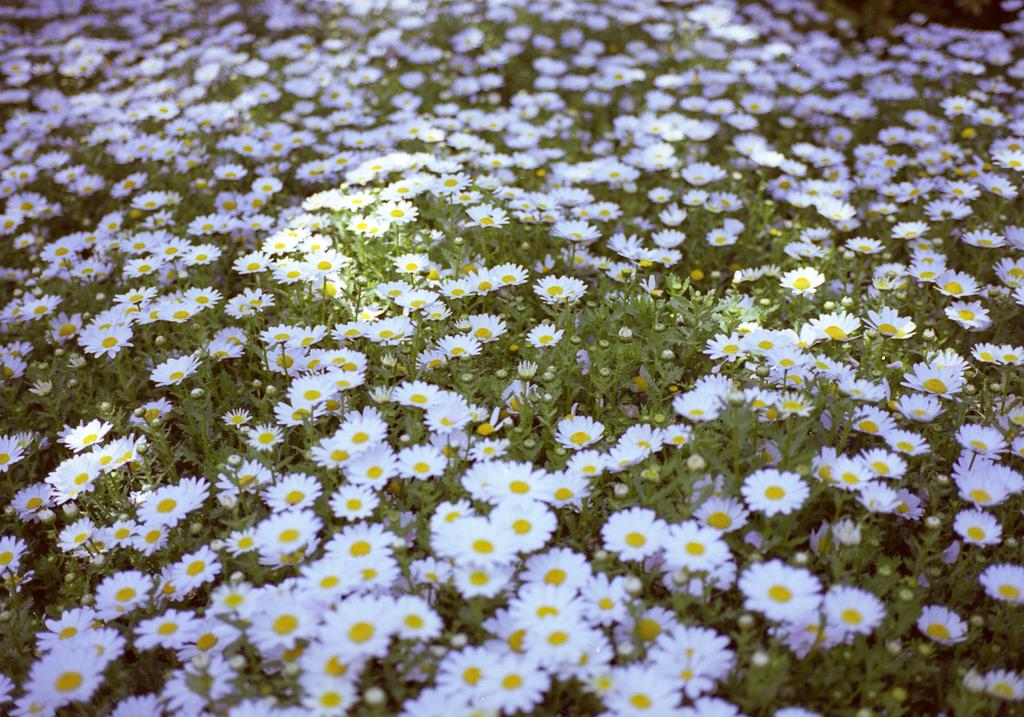What type of plants can be seen in the image? There are many flowers on the plants in the image. Can you describe the flowers in more detail? Unfortunately, the facts provided do not give specific details about the flowers. How many plants are visible in the image? The facts provided do not specify the number of plants in the image. How many pencils can be seen in the image? There is no mention of pencils in the image, so it is not possible to determine how many might be present. 